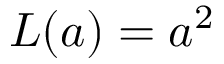<formula> <loc_0><loc_0><loc_500><loc_500>L ( a ) = a ^ { 2 }</formula> 